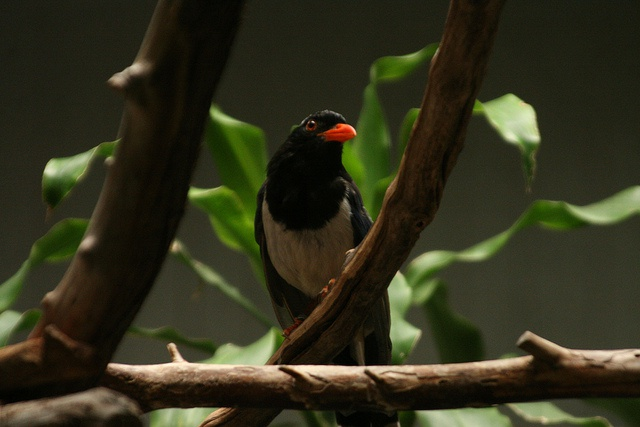Describe the objects in this image and their specific colors. I can see a bird in black, maroon, darkgreen, and gray tones in this image. 